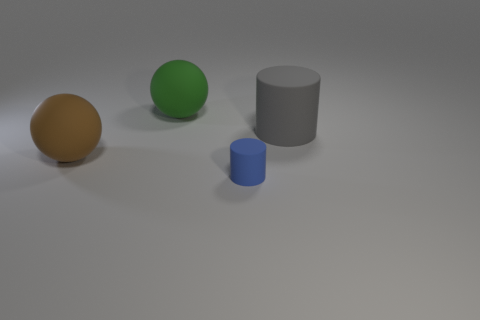Add 3 balls. How many objects exist? 7 Subtract all red blocks. How many purple cylinders are left? 0 Subtract all big yellow metallic objects. Subtract all large green rubber objects. How many objects are left? 3 Add 4 brown rubber balls. How many brown rubber balls are left? 5 Add 4 tiny blue matte objects. How many tiny blue matte objects exist? 5 Subtract all green spheres. How many spheres are left? 1 Subtract 1 blue cylinders. How many objects are left? 3 Subtract 2 balls. How many balls are left? 0 Subtract all cyan balls. Subtract all gray cylinders. How many balls are left? 2 